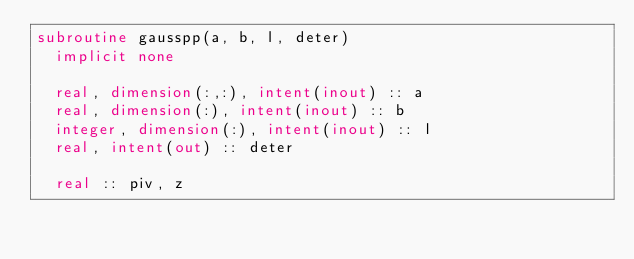<code> <loc_0><loc_0><loc_500><loc_500><_FORTRAN_>subroutine gausspp(a, b, l, deter)
  implicit none

  real, dimension(:,:), intent(inout) :: a
  real, dimension(:), intent(inout) :: b
  integer, dimension(:), intent(inout) :: l
  real, intent(out) :: deter

  real :: piv, z</code> 